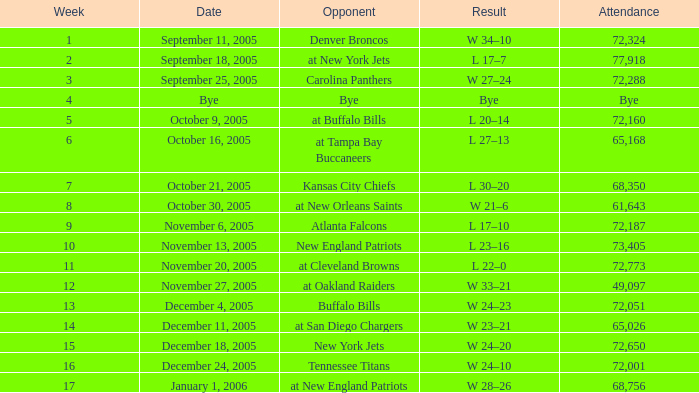During which week was the attendance recorded as 49,097? 12.0. 